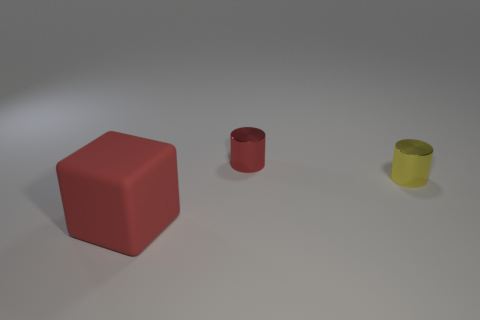Add 3 yellow things. How many objects exist? 6 Subtract all cubes. How many objects are left? 2 Subtract all big brown matte cubes. Subtract all small yellow metallic cylinders. How many objects are left? 2 Add 1 large objects. How many large objects are left? 2 Add 2 tiny brown shiny things. How many tiny brown shiny things exist? 2 Subtract 0 green cylinders. How many objects are left? 3 